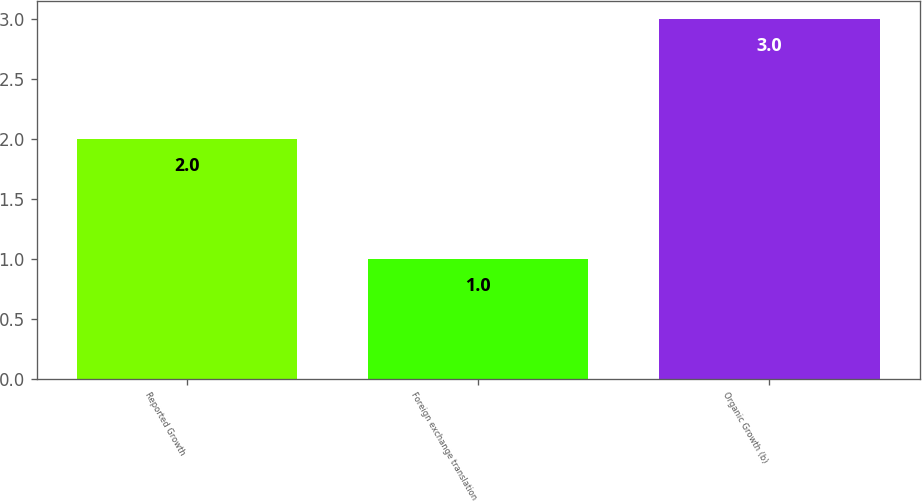Convert chart to OTSL. <chart><loc_0><loc_0><loc_500><loc_500><bar_chart><fcel>Reported Growth<fcel>Foreign exchange translation<fcel>Organic Growth (b)<nl><fcel>2<fcel>1<fcel>3<nl></chart> 